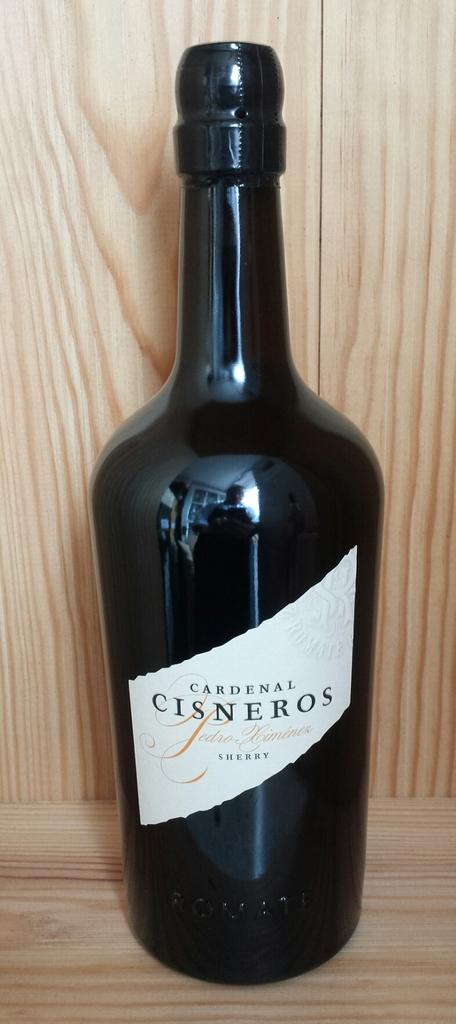<image>
Provide a brief description of the given image. Black bottle of wine which says "Cardenal Cisneros" on it. 